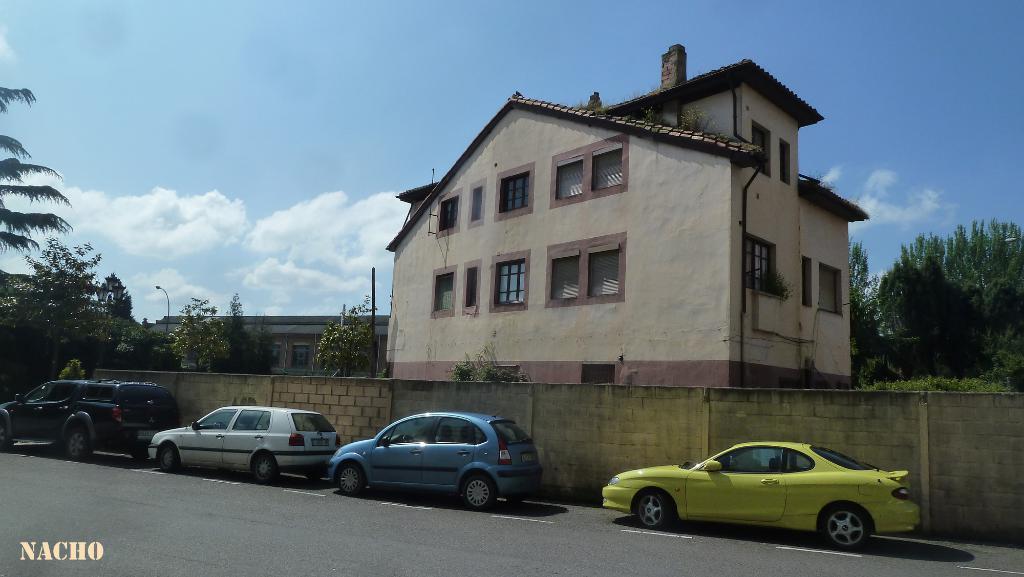Describe this image in one or two sentences. There are some cars parked on the road at the bottom of this image, and there is a wall in the background. We can see there are some trees and buildings in the middle of this image, and there is a cloudy sky at the top of this image. 